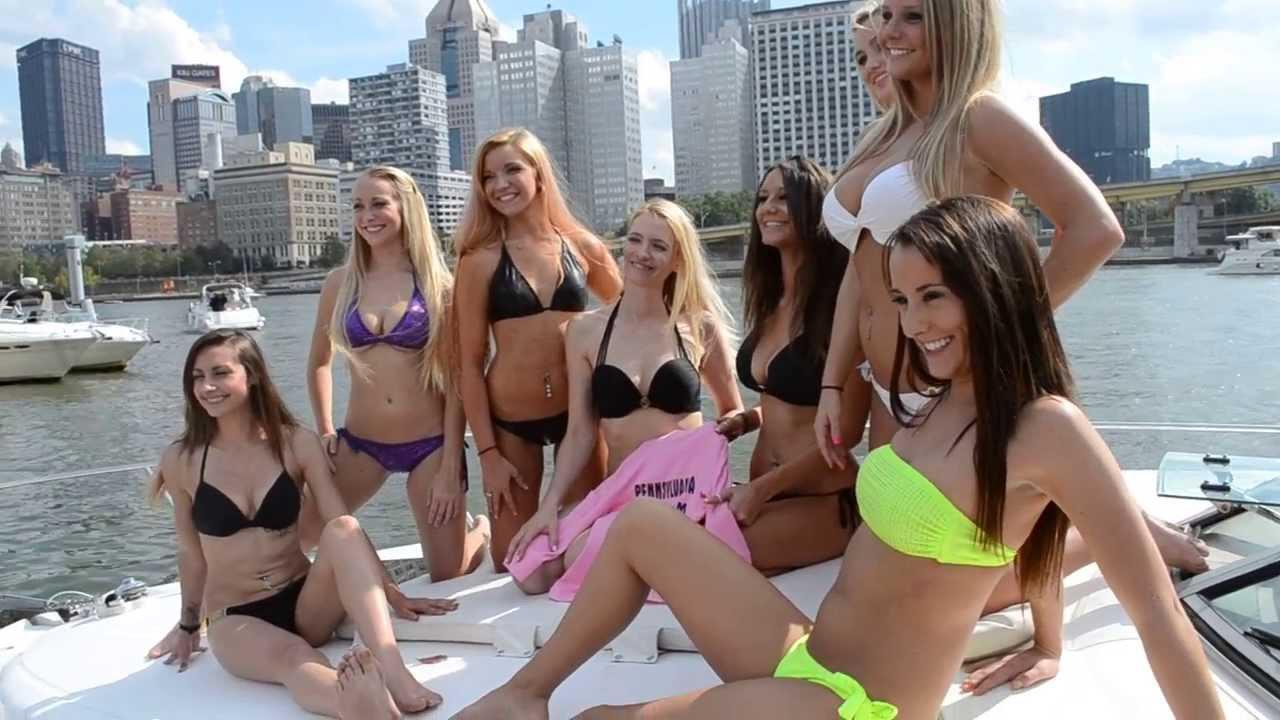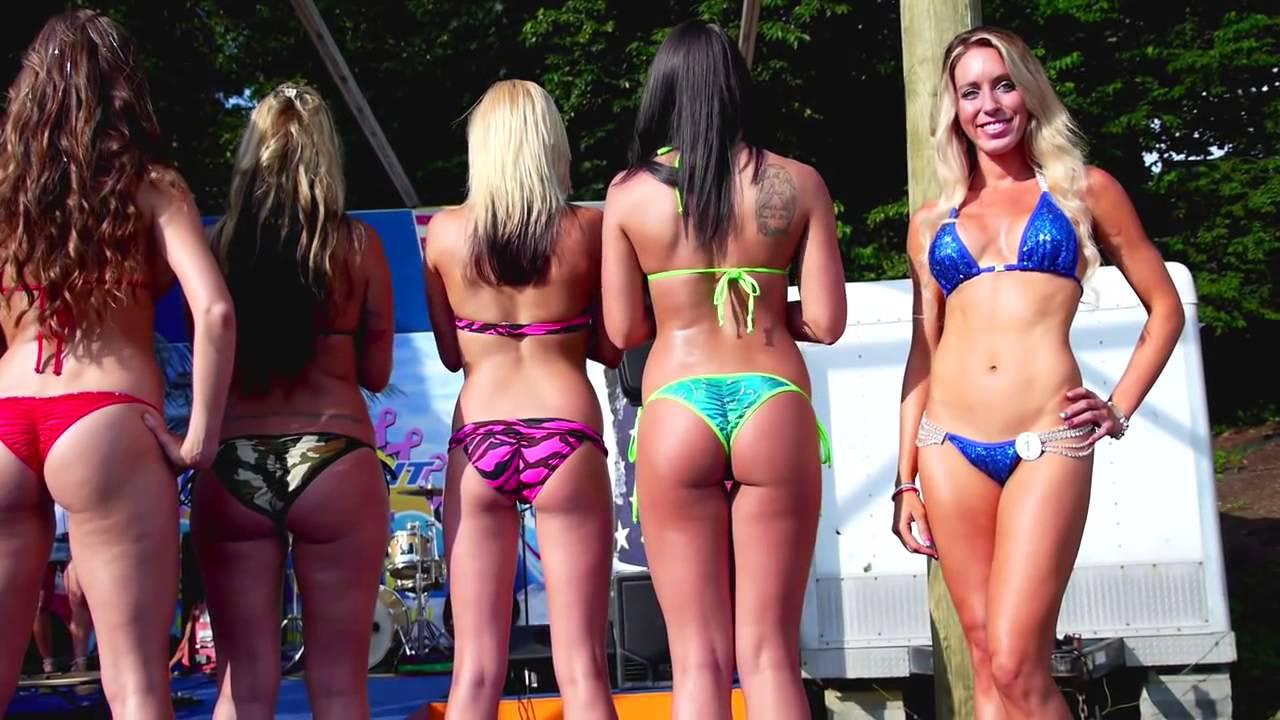The first image is the image on the left, the second image is the image on the right. Analyze the images presented: Is the assertion "In at least one image there is a total of five women in bikinis standing in a row." valid? Answer yes or no. Yes. The first image is the image on the left, the second image is the image on the right. For the images displayed, is the sentence "One girl has her body turned forward and the rest have their rears to the camera in one image." factually correct? Answer yes or no. Yes. 